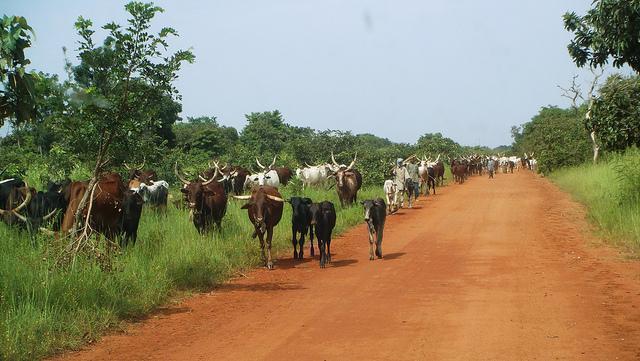What do many of these animals have?
Answer the question by selecting the correct answer among the 4 following choices.
Options: Horns, wings, quills, talons. Horns. What is on the dirt road?
Select the accurate response from the four choices given to answer the question.
Options: Baseball players, eggs, motorcycles, animals. Animals. 